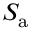<formula> <loc_0><loc_0><loc_500><loc_500>S _ { a }</formula> 